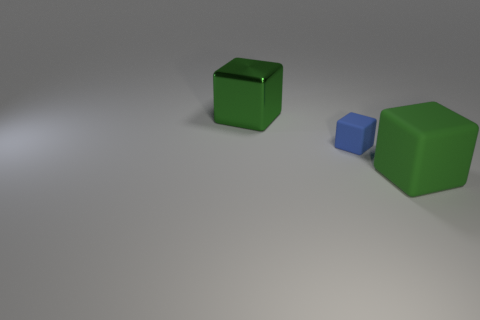Add 1 small yellow cylinders. How many objects exist? 4 Subtract all tiny blue rubber cubes. Subtract all tiny brown metal cubes. How many objects are left? 2 Add 3 big green things. How many big green things are left? 5 Add 3 big red spheres. How many big red spheres exist? 3 Subtract 0 gray blocks. How many objects are left? 3 